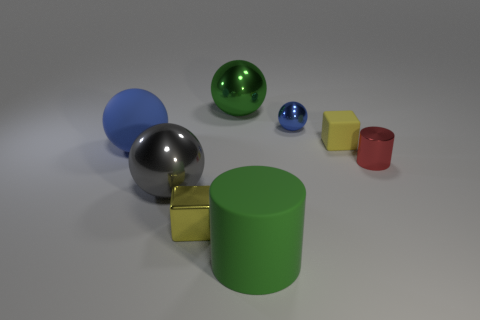What is the size of the shiny object that is the same color as the tiny rubber thing?
Ensure brevity in your answer.  Small. Are there any big metallic balls of the same color as the big rubber cylinder?
Offer a very short reply. Yes. There is a small matte thing; does it have the same color as the tiny shiny thing on the left side of the big matte cylinder?
Give a very brief answer. Yes. How many cubes are either purple shiny objects or red objects?
Keep it short and to the point. 0. Are there any big gray things to the right of the small thing to the right of the rubber block?
Your answer should be very brief. No. Are there any other things that are made of the same material as the small cylinder?
Your answer should be compact. Yes. Does the small yellow metallic thing have the same shape as the big object behind the small blue object?
Give a very brief answer. No. How many other objects are the same size as the blue rubber sphere?
Give a very brief answer. 3. What number of red things are either matte cylinders or big shiny balls?
Keep it short and to the point. 0. How many objects are both behind the red thing and on the left side of the tiny blue shiny object?
Provide a succinct answer. 2. 